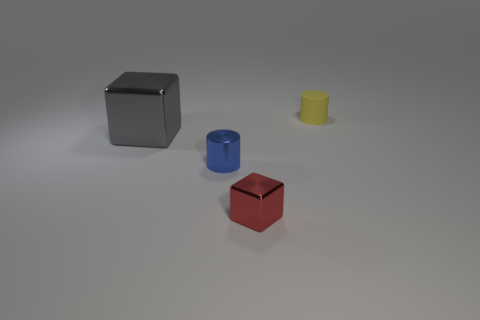Add 1 metallic cubes. How many objects exist? 5 Subtract all gray shiny blocks. Subtract all red blocks. How many objects are left? 2 Add 1 large cubes. How many large cubes are left? 2 Add 4 large gray metal things. How many large gray metal things exist? 5 Subtract 0 brown blocks. How many objects are left? 4 Subtract all yellow cylinders. Subtract all gray blocks. How many cylinders are left? 1 